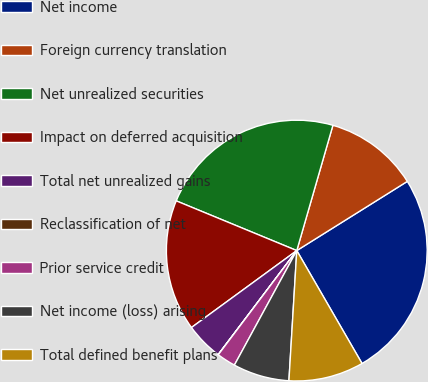Convert chart. <chart><loc_0><loc_0><loc_500><loc_500><pie_chart><fcel>Net income<fcel>Foreign currency translation<fcel>Net unrealized securities<fcel>Impact on deferred acquisition<fcel>Total net unrealized gains<fcel>Reclassification of net<fcel>Prior service credit<fcel>Net income (loss) arising<fcel>Total defined benefit plans<nl><fcel>25.56%<fcel>11.63%<fcel>23.24%<fcel>16.27%<fcel>4.66%<fcel>0.02%<fcel>2.34%<fcel>6.98%<fcel>9.3%<nl></chart> 